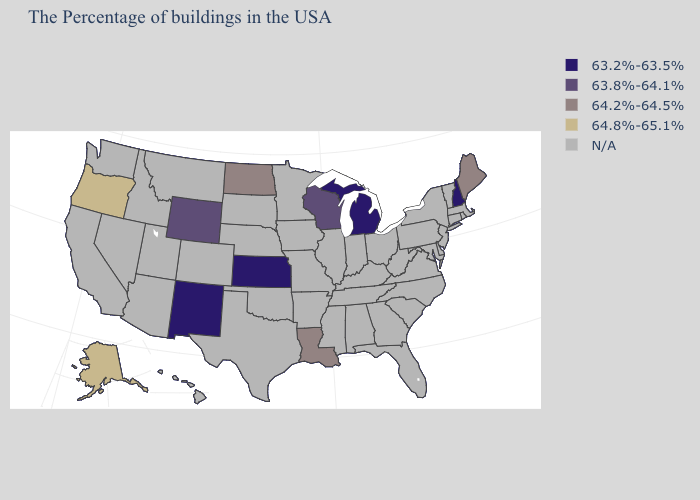What is the highest value in the MidWest ?
Concise answer only. 64.2%-64.5%. Name the states that have a value in the range 64.8%-65.1%?
Keep it brief. Oregon, Alaska. What is the lowest value in the USA?
Quick response, please. 63.2%-63.5%. Does the map have missing data?
Short answer required. Yes. Name the states that have a value in the range 63.2%-63.5%?
Quick response, please. New Hampshire, Michigan, Kansas, New Mexico. What is the highest value in states that border Utah?
Answer briefly. 63.8%-64.1%. What is the value of Florida?
Concise answer only. N/A. What is the value of Maine?
Write a very short answer. 64.2%-64.5%. What is the lowest value in the USA?
Quick response, please. 63.2%-63.5%. Name the states that have a value in the range N/A?
Concise answer only. Massachusetts, Rhode Island, Vermont, Connecticut, New York, New Jersey, Delaware, Maryland, Pennsylvania, Virginia, North Carolina, South Carolina, West Virginia, Ohio, Florida, Georgia, Kentucky, Indiana, Alabama, Tennessee, Illinois, Mississippi, Missouri, Arkansas, Minnesota, Iowa, Nebraska, Oklahoma, Texas, South Dakota, Colorado, Utah, Montana, Arizona, Idaho, Nevada, California, Washington, Hawaii. Name the states that have a value in the range N/A?
Answer briefly. Massachusetts, Rhode Island, Vermont, Connecticut, New York, New Jersey, Delaware, Maryland, Pennsylvania, Virginia, North Carolina, South Carolina, West Virginia, Ohio, Florida, Georgia, Kentucky, Indiana, Alabama, Tennessee, Illinois, Mississippi, Missouri, Arkansas, Minnesota, Iowa, Nebraska, Oklahoma, Texas, South Dakota, Colorado, Utah, Montana, Arizona, Idaho, Nevada, California, Washington, Hawaii. Does New Hampshire have the lowest value in the Northeast?
Quick response, please. Yes. 